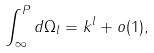<formula> <loc_0><loc_0><loc_500><loc_500>\int _ { \infty } ^ { P } d \Omega _ { l } = k ^ { l } + o ( 1 ) ,</formula> 